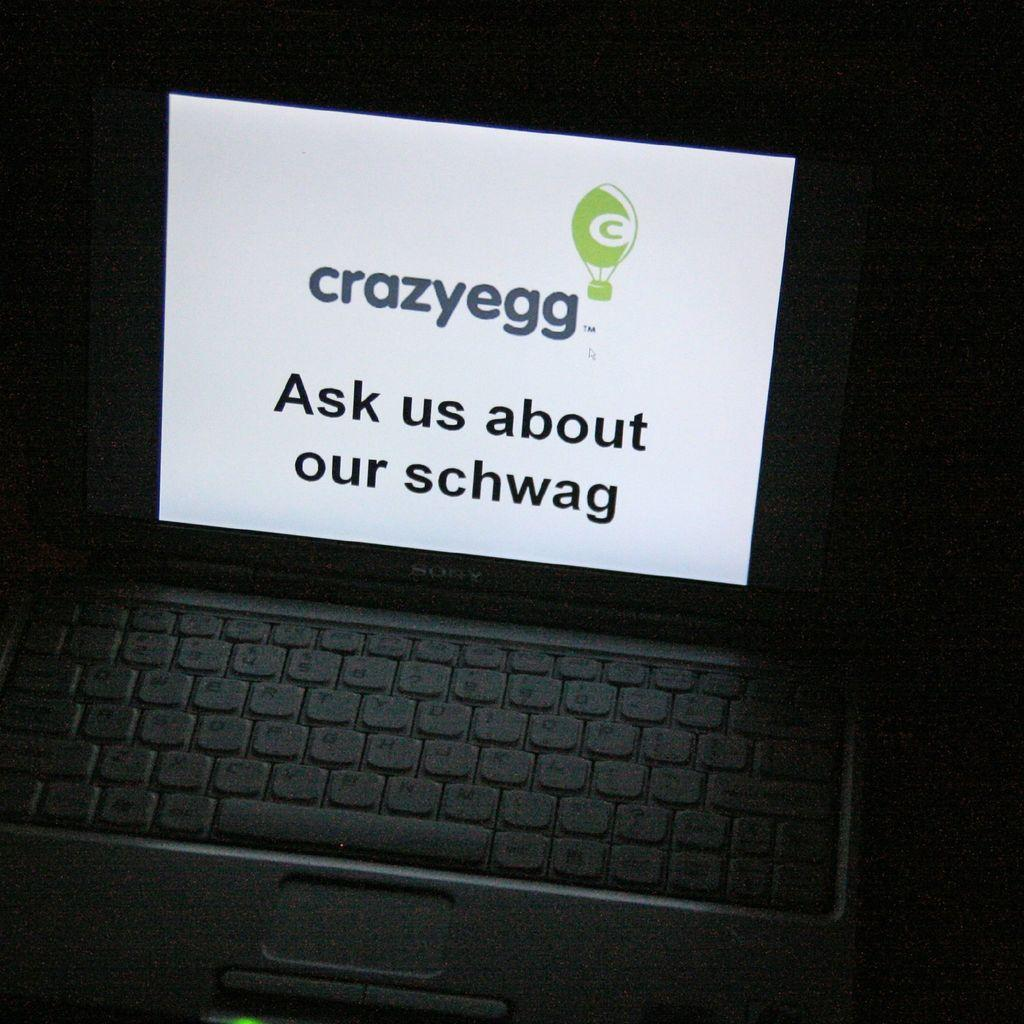<image>
Write a terse but informative summary of the picture. A laptop is open to an advert for something called crazyegg. 